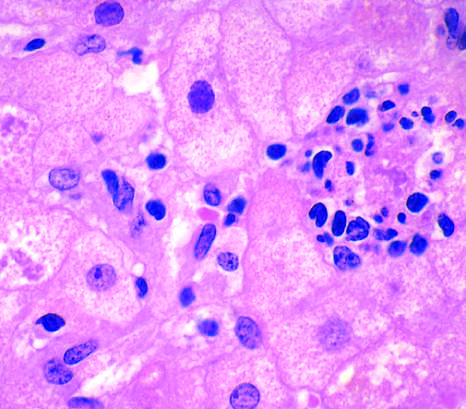s cell present in another hepatocyte?
Answer the question using a single word or phrase. No 